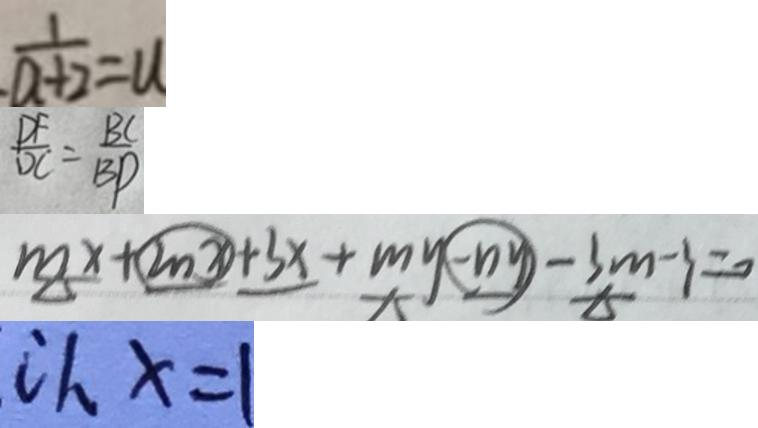Convert formula to latex. <formula><loc_0><loc_0><loc_500><loc_500>\frac { 1 } { a + 2 } = u 
 \frac { D F } { D C } = \frac { B C } { B D } 
 m x + 2 n x + 3 x + m y - n y - 3 m - 3 = 0 
 c h x = 1</formula> 